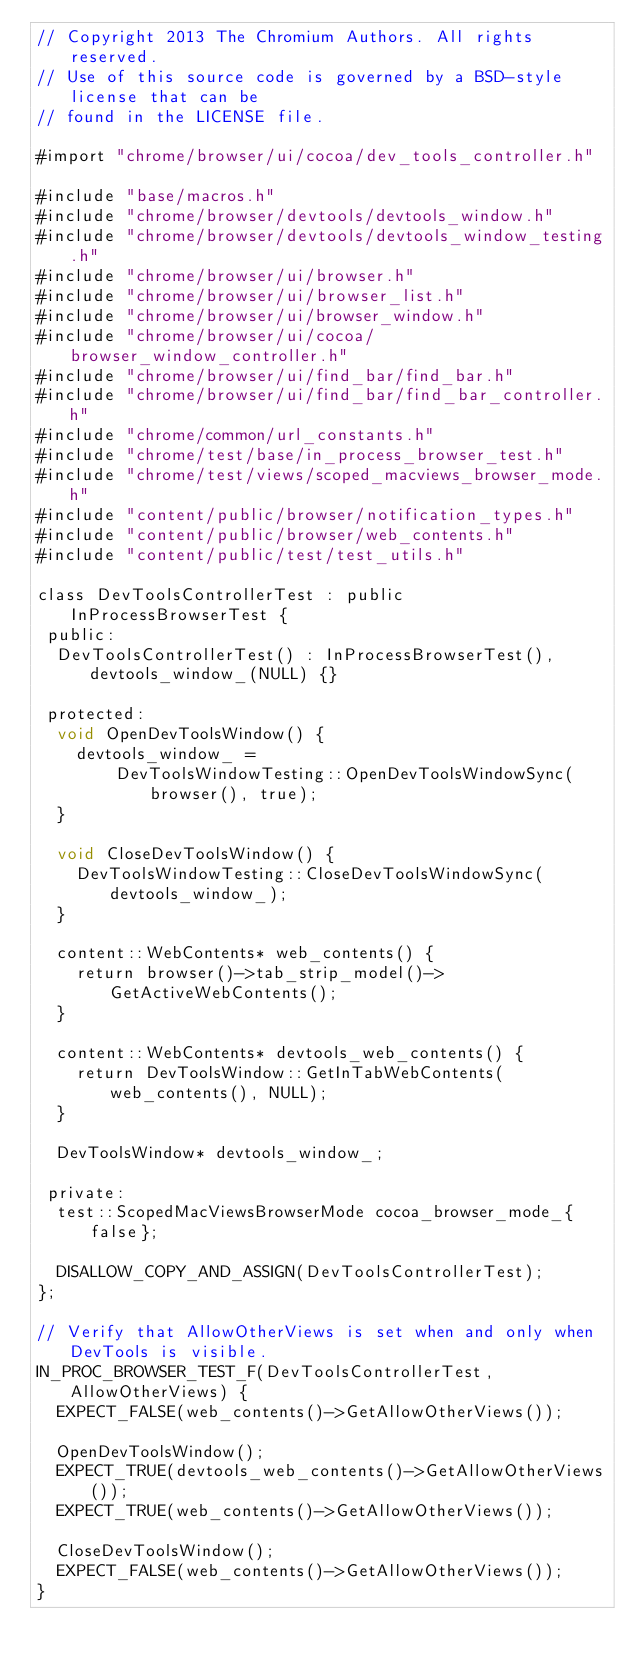<code> <loc_0><loc_0><loc_500><loc_500><_ObjectiveC_>// Copyright 2013 The Chromium Authors. All rights reserved.
// Use of this source code is governed by a BSD-style license that can be
// found in the LICENSE file.

#import "chrome/browser/ui/cocoa/dev_tools_controller.h"

#include "base/macros.h"
#include "chrome/browser/devtools/devtools_window.h"
#include "chrome/browser/devtools/devtools_window_testing.h"
#include "chrome/browser/ui/browser.h"
#include "chrome/browser/ui/browser_list.h"
#include "chrome/browser/ui/browser_window.h"
#include "chrome/browser/ui/cocoa/browser_window_controller.h"
#include "chrome/browser/ui/find_bar/find_bar.h"
#include "chrome/browser/ui/find_bar/find_bar_controller.h"
#include "chrome/common/url_constants.h"
#include "chrome/test/base/in_process_browser_test.h"
#include "chrome/test/views/scoped_macviews_browser_mode.h"
#include "content/public/browser/notification_types.h"
#include "content/public/browser/web_contents.h"
#include "content/public/test/test_utils.h"

class DevToolsControllerTest : public InProcessBrowserTest {
 public:
  DevToolsControllerTest() : InProcessBrowserTest(), devtools_window_(NULL) {}

 protected:
  void OpenDevToolsWindow() {
    devtools_window_ =
        DevToolsWindowTesting::OpenDevToolsWindowSync(browser(), true);
  }

  void CloseDevToolsWindow() {
    DevToolsWindowTesting::CloseDevToolsWindowSync(devtools_window_);
  }

  content::WebContents* web_contents() {
    return browser()->tab_strip_model()->GetActiveWebContents();
  }

  content::WebContents* devtools_web_contents() {
    return DevToolsWindow::GetInTabWebContents(web_contents(), NULL);
  }

  DevToolsWindow* devtools_window_;

 private:
  test::ScopedMacViewsBrowserMode cocoa_browser_mode_{false};

  DISALLOW_COPY_AND_ASSIGN(DevToolsControllerTest);
};

// Verify that AllowOtherViews is set when and only when DevTools is visible.
IN_PROC_BROWSER_TEST_F(DevToolsControllerTest, AllowOtherViews) {
  EXPECT_FALSE(web_contents()->GetAllowOtherViews());

  OpenDevToolsWindow();
  EXPECT_TRUE(devtools_web_contents()->GetAllowOtherViews());
  EXPECT_TRUE(web_contents()->GetAllowOtherViews());

  CloseDevToolsWindow();
  EXPECT_FALSE(web_contents()->GetAllowOtherViews());
}
</code> 